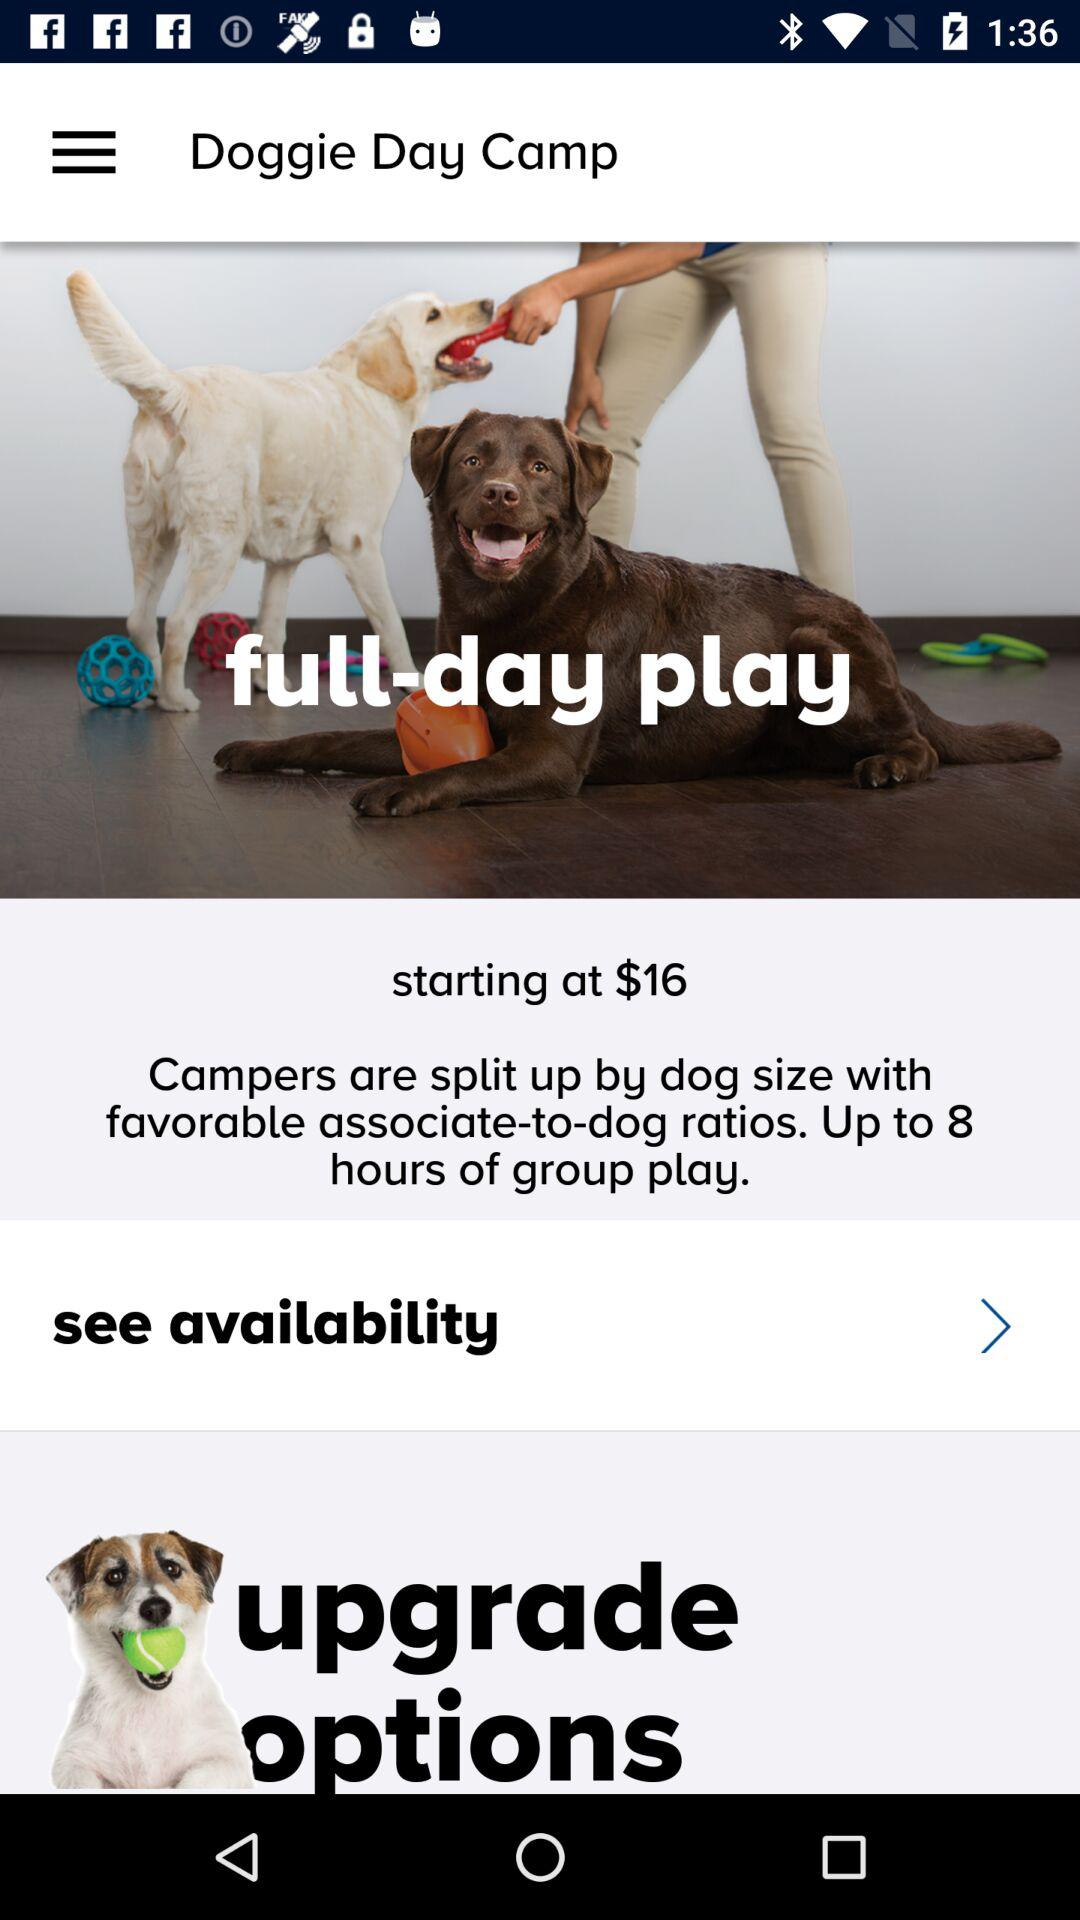What is the starting price for full-day play? The starting price is $16. 